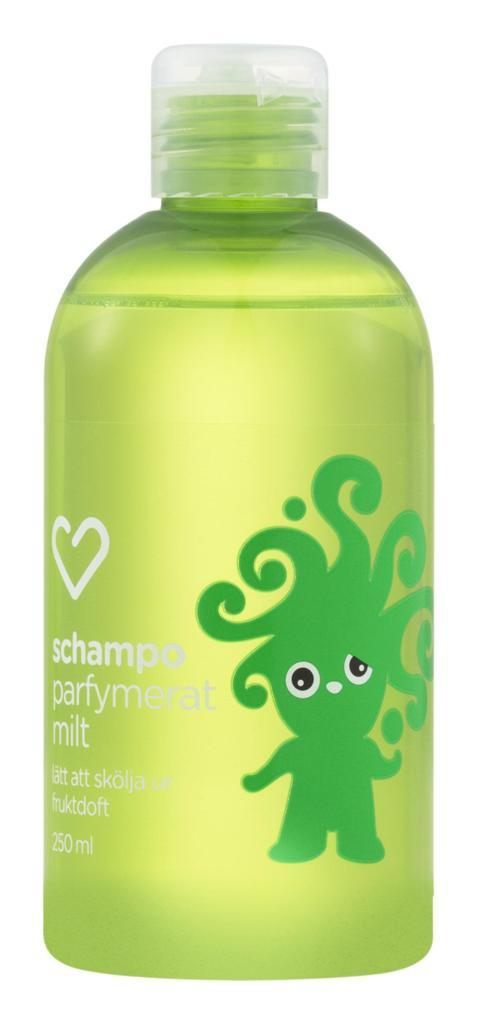<image>
Share a concise interpretation of the image provided. A 250ml bottle of a green shampoo has a green cartoon figure with long wild hair on it. 